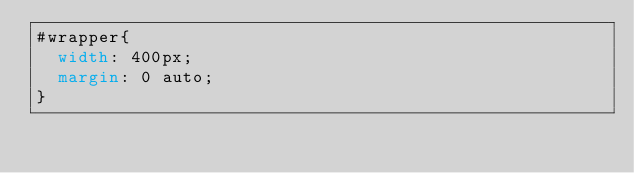Convert code to text. <code><loc_0><loc_0><loc_500><loc_500><_CSS_>#wrapper{
  width: 400px;
  margin: 0 auto;
}</code> 